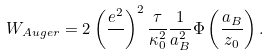Convert formula to latex. <formula><loc_0><loc_0><loc_500><loc_500>W _ { A u g e r } = 2 \left ( { \frac { e ^ { 2 } } { } } \right ) ^ { 2 } { \frac { \tau } { \kappa _ { 0 } ^ { 2 } } } { \frac { 1 } { a _ { B } ^ { 2 } } } \Phi \left ( { \frac { a _ { B } } { z _ { 0 } } } \right ) .</formula> 